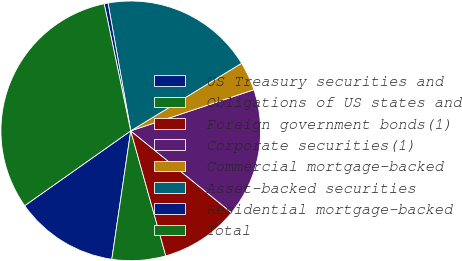Convert chart. <chart><loc_0><loc_0><loc_500><loc_500><pie_chart><fcel>US Treasury securities and<fcel>Obligations of US states and<fcel>Foreign government bonds(1)<fcel>Corporate securities(1)<fcel>Commercial mortgage-backed<fcel>Asset-backed securities<fcel>Residential mortgage-backed<fcel>Total<nl><fcel>12.89%<fcel>6.68%<fcel>9.79%<fcel>15.99%<fcel>3.58%<fcel>19.09%<fcel>0.48%<fcel>31.5%<nl></chart> 